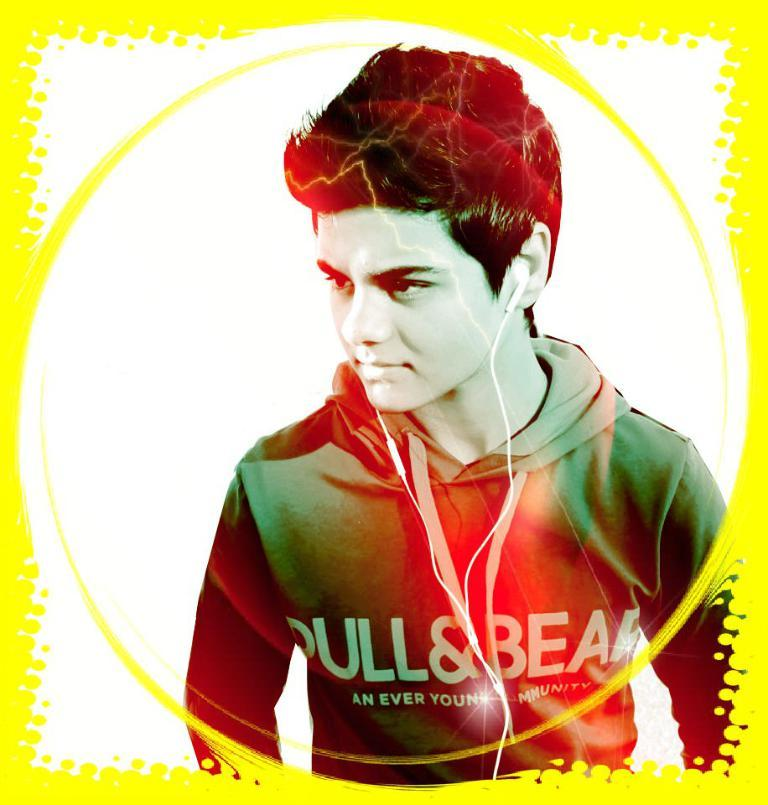<image>
Render a clear and concise summary of the photo. The individual is wearing a pullover with Pull & Bear is written across their chest. 